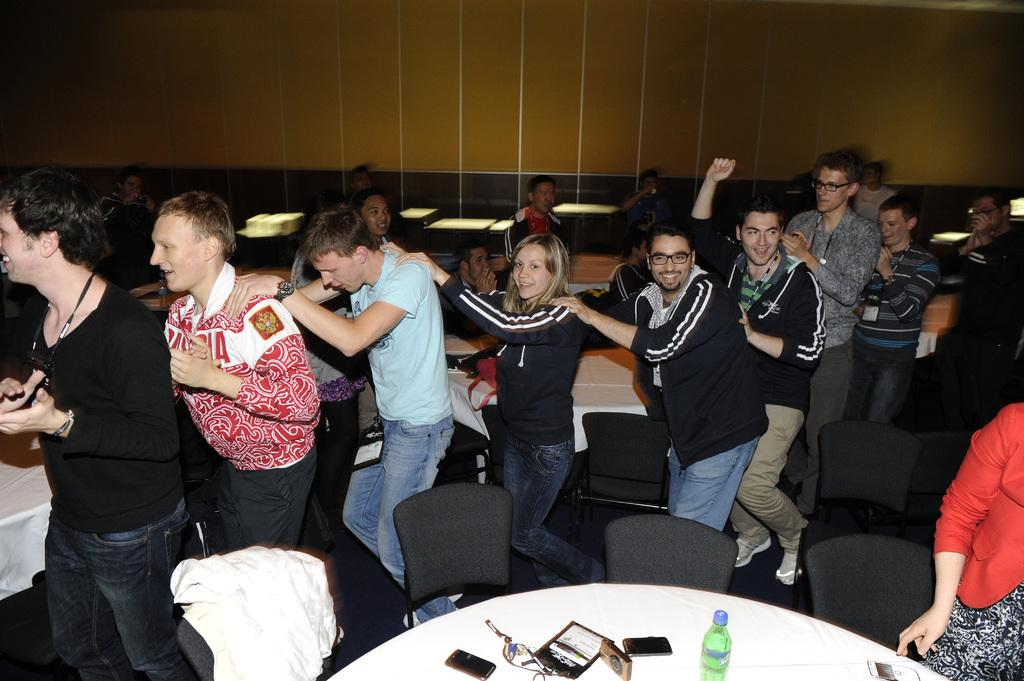How many people can be seen in the image? There are several people in the image. What are the people doing in the image? The people are following each other in a row and walking around. What can be seen in the background of the image? There are many tables in the background of the image. What type of mark can be seen on the underwear of the person in the front of the row? There is no underwear visible in the image, and therefore no marks can be observed. 